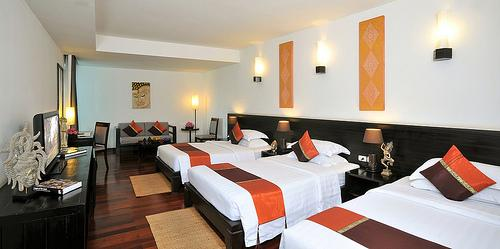Identify the color and type of decoration on the wall near the left corner. The decoration is an orange and white wall hanging. Tell me what's on the stand next to the television. There is a book on the stand next to the television. What type of floor is shown in the image and specify its color. The floor is a light brown hard wood floor. List the items found on the wood floor in the image. There is a rug and a small mat on the wood floor. What is the color of the sofa at the end of the room? The sofa at the end of the room is white. 